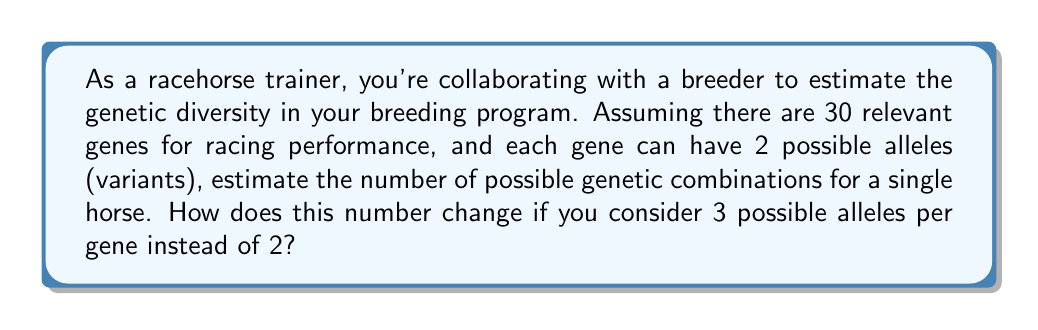Teach me how to tackle this problem. To solve this problem, we need to use the fundamental counting principle. For each gene, we have a choice of alleles, and we multiply these choices for all genes.

1. With 2 possible alleles per gene:
   - For each of the 30 genes, we have 2 choices.
   - The total number of combinations is therefore $2^{30}$.

   $$\text{Number of combinations} = 2^{30} = 1,073,741,824$$

2. With 3 possible alleles per gene:
   - Now, for each of the 30 genes, we have 3 choices.
   - The total number of combinations becomes $3^{30}$.

   $$\text{Number of combinations} = 3^{30} = 205,891,132,094,649$$

To compare:
$$\frac{3^{30}}{2^{30}} = \frac{205,891,132,094,649}{1,073,741,824} \approx 191,751.69$$

This means that increasing from 2 to 3 alleles per gene increases the number of possible combinations by a factor of about 191,752.

This vast increase in possible combinations illustrates why considering more alleles dramatically increases genetic diversity, which could be crucial for breeding programs aiming to produce horses with specific traits or performance characteristics.
Answer: With 2 alleles per gene: $2^{30} = 1,073,741,824$ combinations
With 3 alleles per gene: $3^{30} = 205,891,132,094,649$ combinations
The number of combinations increases by a factor of approximately 191,752. 